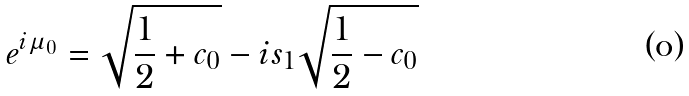Convert formula to latex. <formula><loc_0><loc_0><loc_500><loc_500>e ^ { i \mu _ { 0 } } = \sqrt { \frac { 1 } { 2 } + c _ { 0 } } - i s _ { 1 } \sqrt { \frac { 1 } { 2 } - c _ { 0 } }</formula> 